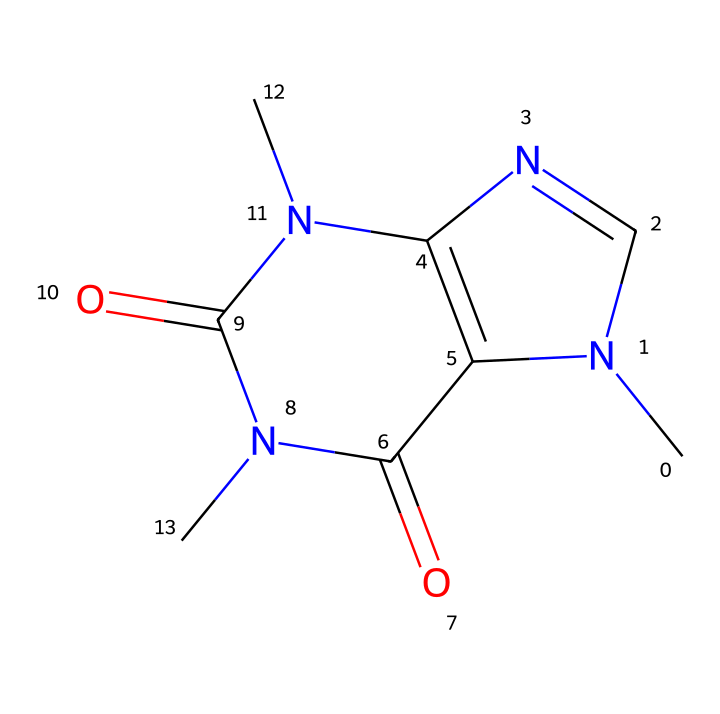What is the chemical name of this compound? The provided SMILES representation corresponds to a known stimulant compound that is commonly found in beverages like coffee. The standard IUPAC name for this molecule is caffeine, which is derived from its structural components and characteristics as a central nervous system stimulant.
Answer: caffeine How many nitrogen atoms are present in the structure? By examining the chemical structure represented by the SMILES, we identify the nitrogen atoms (N) indicated in the sequence. There are four nitrogen atoms present in the caffeine structure.
Answer: four What functional group is present due to the carbonyl oxygen? In the structure, the carbonyl functional groups are represented by C=O bonds. These carbonyls are indicative of amides in the case of caffeine, given the adjacent nitrogen atoms, leading to this being classified primarily under amide functionalities.
Answer: amide What is the molecular formula of caffeine? To derive the molecular formula from the SMILES representation, we can count the atoms represented: carbon (C), hydrogen (H), nitrogen (N), and oxygen (O) atoms. The total gives the formula C8H10N4O2.
Answer: C8H10N4O2 What type of compound is caffeine classified as? Caffeine is categorized based on its structure and effects as a stimulant. The presence of multiple nitrogen atoms and its physiological effects categorize caffeine as an alkaloid, common in medicinal compounds.
Answer: alkaloid What is the total number of rings in this structure? Upon analyzing the structure, we observe that caffeine possesses two fused rings which are typical in some alkaloids. This can be counted directly from the connectivity in the cyclic structure of caffeine.
Answer: two 